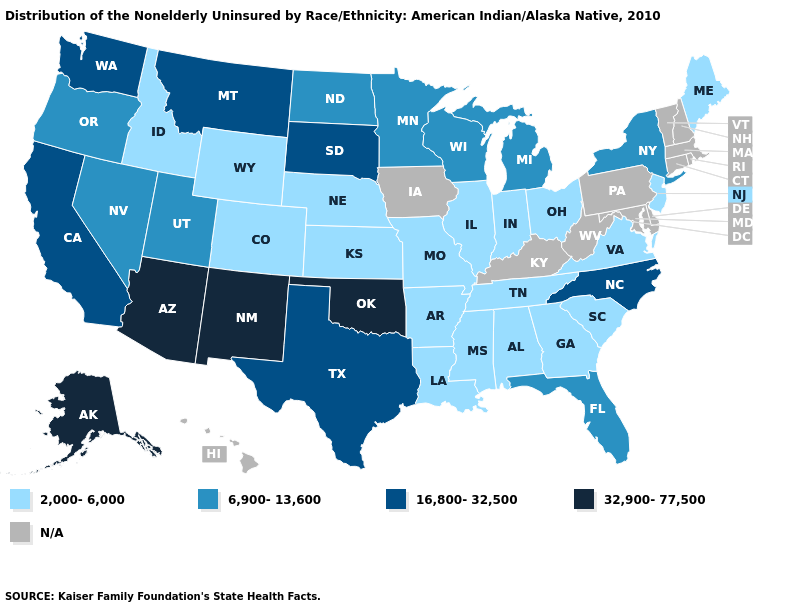Name the states that have a value in the range 2,000-6,000?
Write a very short answer. Alabama, Arkansas, Colorado, Georgia, Idaho, Illinois, Indiana, Kansas, Louisiana, Maine, Mississippi, Missouri, Nebraska, New Jersey, Ohio, South Carolina, Tennessee, Virginia, Wyoming. Among the states that border Louisiana , does Arkansas have the highest value?
Quick response, please. No. What is the highest value in states that border Pennsylvania?
Concise answer only. 6,900-13,600. Does the map have missing data?
Quick response, please. Yes. What is the highest value in the South ?
Quick response, please. 32,900-77,500. Which states have the highest value in the USA?
Be succinct. Alaska, Arizona, New Mexico, Oklahoma. Does Florida have the lowest value in the South?
Be succinct. No. What is the value of Idaho?
Keep it brief. 2,000-6,000. Which states have the lowest value in the USA?
Be succinct. Alabama, Arkansas, Colorado, Georgia, Idaho, Illinois, Indiana, Kansas, Louisiana, Maine, Mississippi, Missouri, Nebraska, New Jersey, Ohio, South Carolina, Tennessee, Virginia, Wyoming. What is the highest value in the Northeast ?
Keep it brief. 6,900-13,600. Does Virginia have the lowest value in the South?
Answer briefly. Yes. Name the states that have a value in the range 6,900-13,600?
Quick response, please. Florida, Michigan, Minnesota, Nevada, New York, North Dakota, Oregon, Utah, Wisconsin. Which states hav the highest value in the South?
Short answer required. Oklahoma. What is the value of Pennsylvania?
Quick response, please. N/A. 